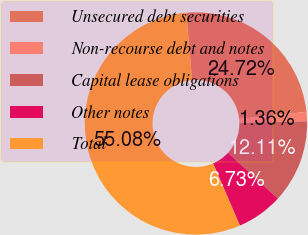<chart> <loc_0><loc_0><loc_500><loc_500><pie_chart><fcel>Unsecured debt securities<fcel>Non-recourse debt and notes<fcel>Capital lease obligations<fcel>Other notes<fcel>Total<nl><fcel>24.72%<fcel>1.36%<fcel>12.11%<fcel>6.73%<fcel>55.08%<nl></chart> 